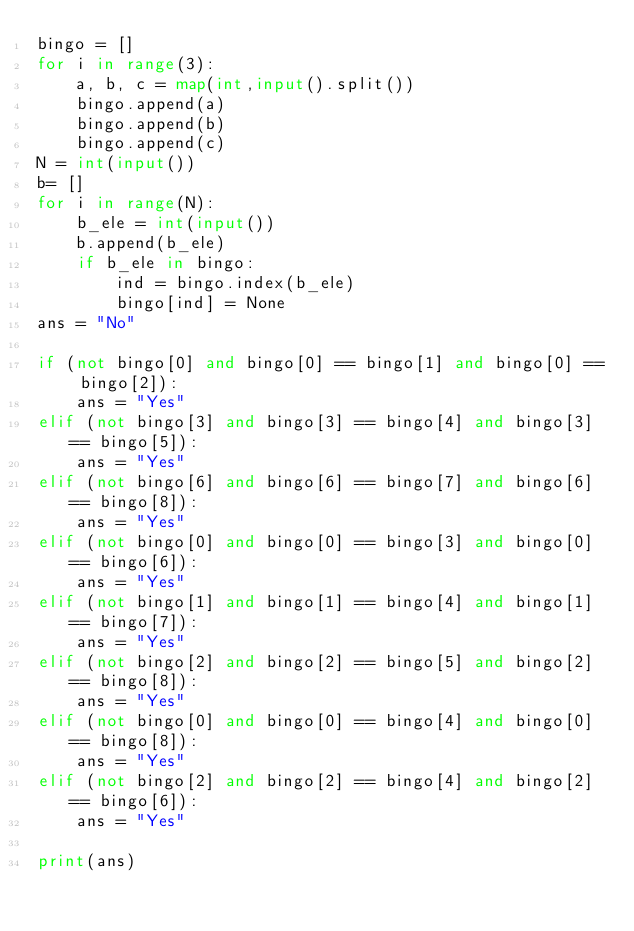Convert code to text. <code><loc_0><loc_0><loc_500><loc_500><_Python_>bingo = []
for i in range(3):
    a, b, c = map(int,input().split())
    bingo.append(a)
    bingo.append(b)
    bingo.append(c)
N = int(input())
b= []
for i in range(N):
    b_ele = int(input())
    b.append(b_ele)
    if b_ele in bingo:
        ind = bingo.index(b_ele)
        bingo[ind] = None
ans = "No"

if (not bingo[0] and bingo[0] == bingo[1] and bingo[0] == bingo[2]):
    ans = "Yes"
elif (not bingo[3] and bingo[3] == bingo[4] and bingo[3] == bingo[5]):
    ans = "Yes"
elif (not bingo[6] and bingo[6] == bingo[7] and bingo[6] == bingo[8]):
    ans = "Yes"
elif (not bingo[0] and bingo[0] == bingo[3] and bingo[0] == bingo[6]):
    ans = "Yes"
elif (not bingo[1] and bingo[1] == bingo[4] and bingo[1] == bingo[7]):
    ans = "Yes"
elif (not bingo[2] and bingo[2] == bingo[5] and bingo[2] == bingo[8]):
    ans = "Yes"
elif (not bingo[0] and bingo[0] == bingo[4] and bingo[0] == bingo[8]):
    ans = "Yes"
elif (not bingo[2] and bingo[2] == bingo[4] and bingo[2] == bingo[6]):
    ans = "Yes"

print(ans)
</code> 